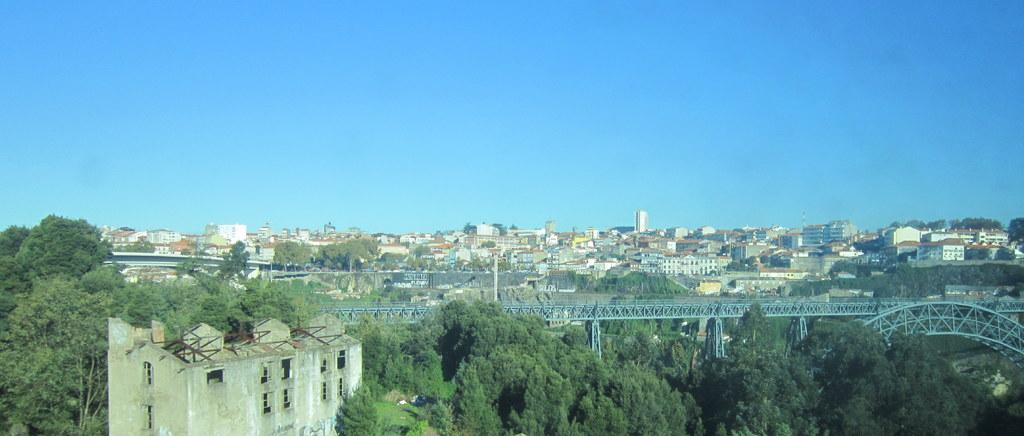Could you give a brief overview of what you see in this image? In this picture I can see bridge, buildings, trees, and in the background there is sky. 